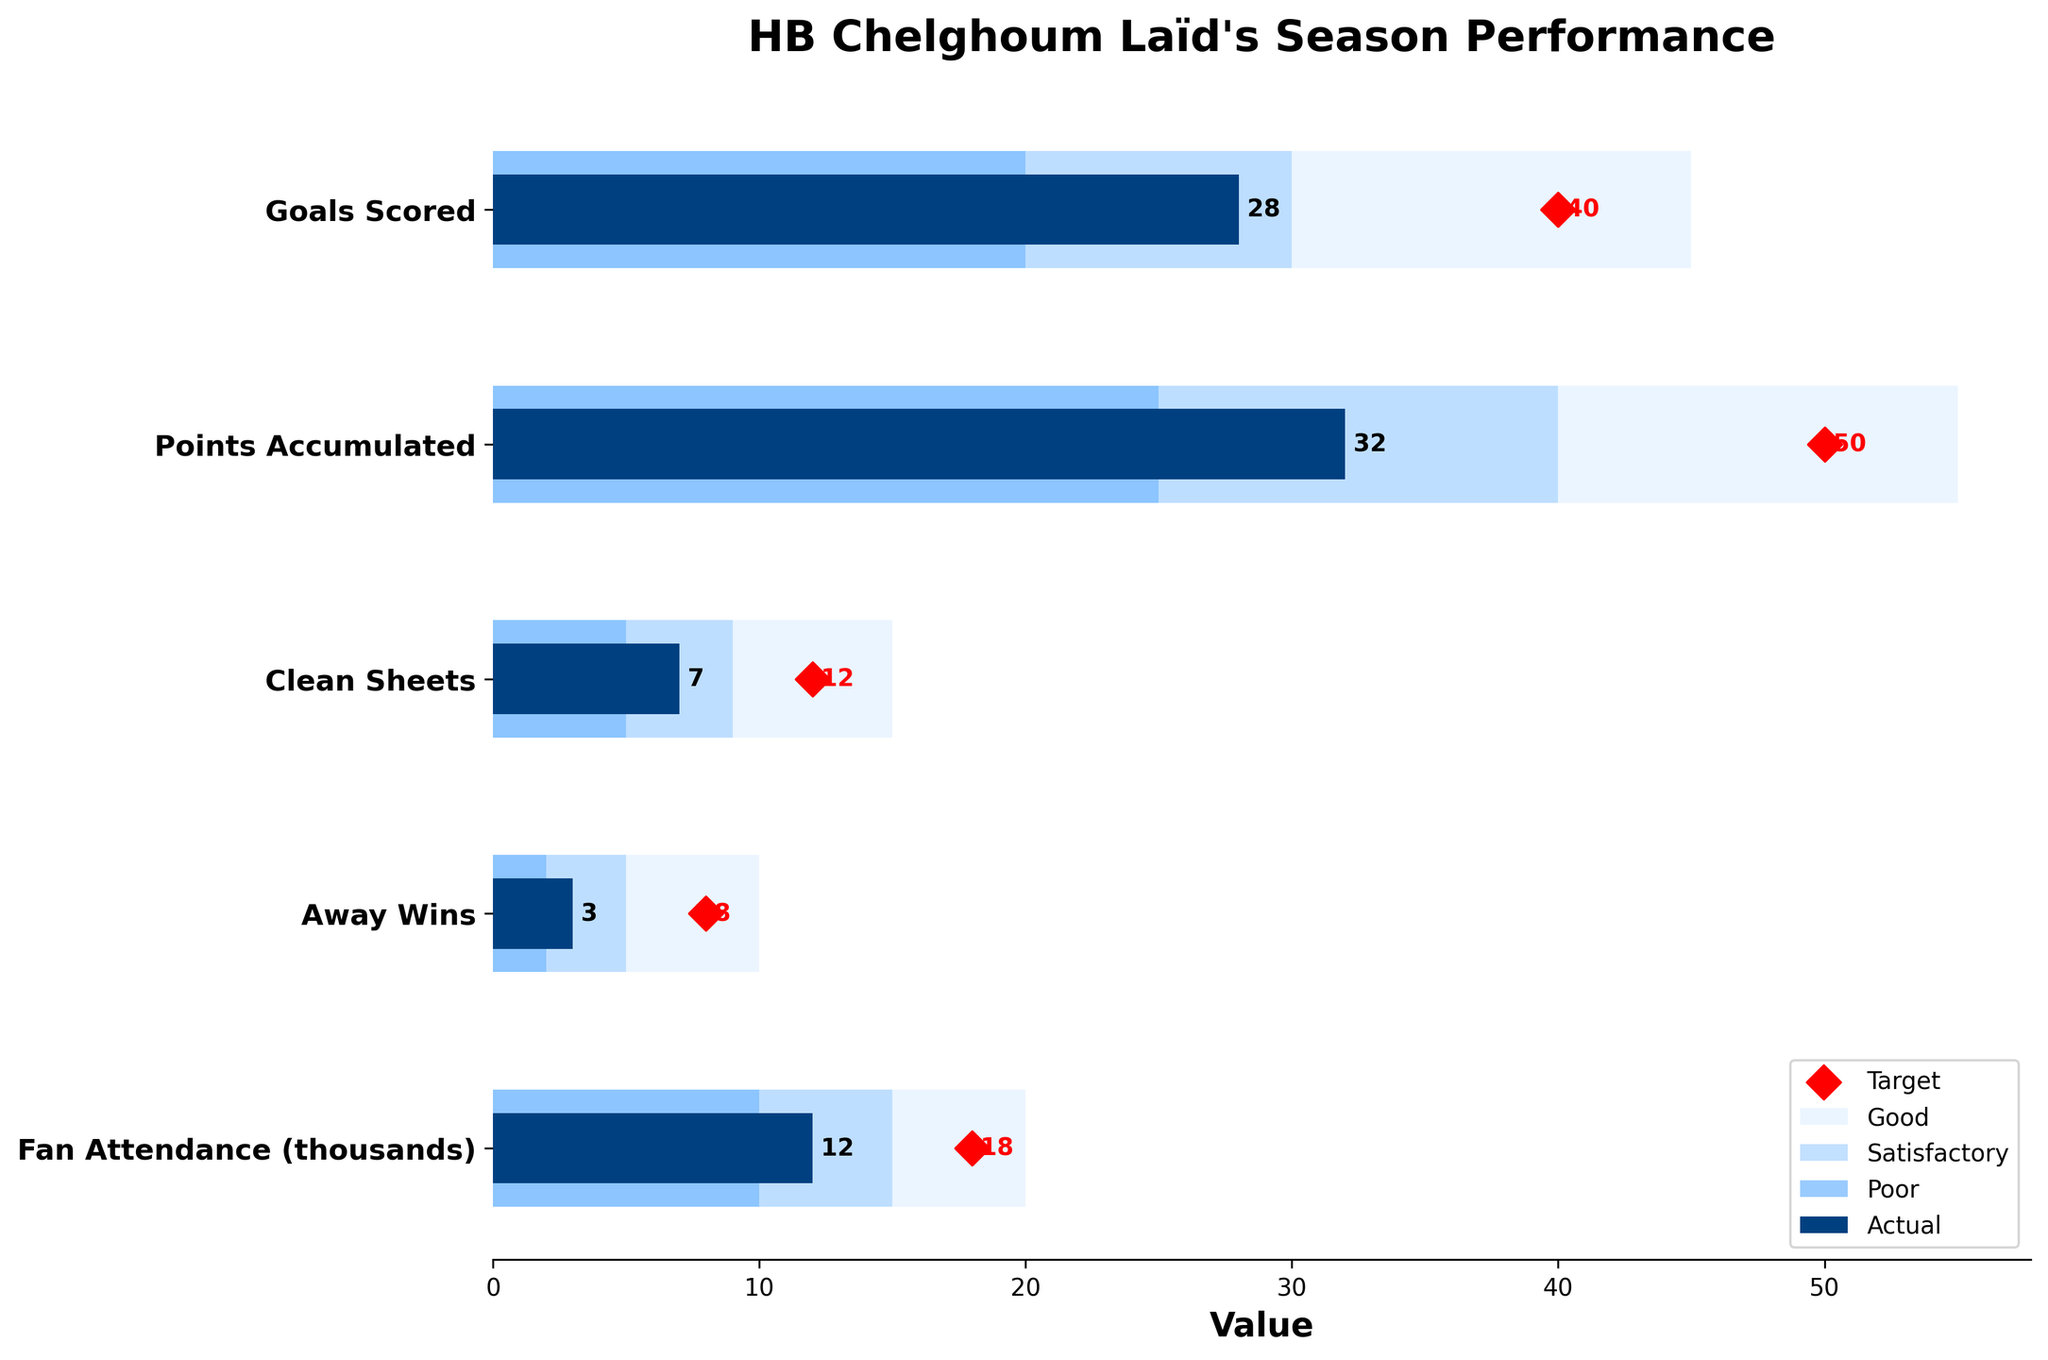what is the title of the figure? The title of the figure is displayed at the top of the chart. It reads "HB Chelghoum Laïd's Season Performance".
Answer: HB Chelghoum Laïd's Season Performance How many goals has HB Chelghoum Laïd scored compared to the target? The bar for "Goals Scored" shows an actual value of 28, and there's a red diamond marker showing the target value of 40.
Answer: 28 out of 40 What's the difference between the actual points accumulated and the target? The points accumulated are shown in the bar with the actual value as 32 and the target marked with a red diamond at 50. The difference is 50 - 32.
Answer: 18 Which category has the highest target value? By comparing the red diamond markers, we see that "Points Accumulated" has the highest target value of 50.
Answer: Points Accumulated What color represents the 'Good' performance zone and what does it mean in terms of fan attendance? In the bar chart, the light blue color represents the 'Good' performance zone. For "Fan Attendance (thousands)", the span of the 'Good' zone is from 15 to 20 thousand fans.
Answer: light blue, 15-20 thousand How many away wins does the team have compared to the satisfactory performance range? The actual number of away wins is shown as 3. The satisfactory zone for away wins ranges from 5 to 8. So, 3 falls short of the satisfactory range.
Answer: 3, below satisfactory What's the difference between the satisfactory and good performance ranges for clean sheets? For "Clean Sheets", the satisfactory range goes from 9 to 12 and the good performance starts at 12, ending at 15. The difference between 12 (start of "good") and 9 (start of "satisfactory") is 3.
Answer: 3 In which categories is the actual performance above the poor but below the target? Comparing the actual values with the ranges, both "Clean Sheets" (actual 7, poor 5-9) and "Away Wins" (actual 3, poor 2-5) are within the poor range but below target.
Answer: Clean Sheets, Away Wins 